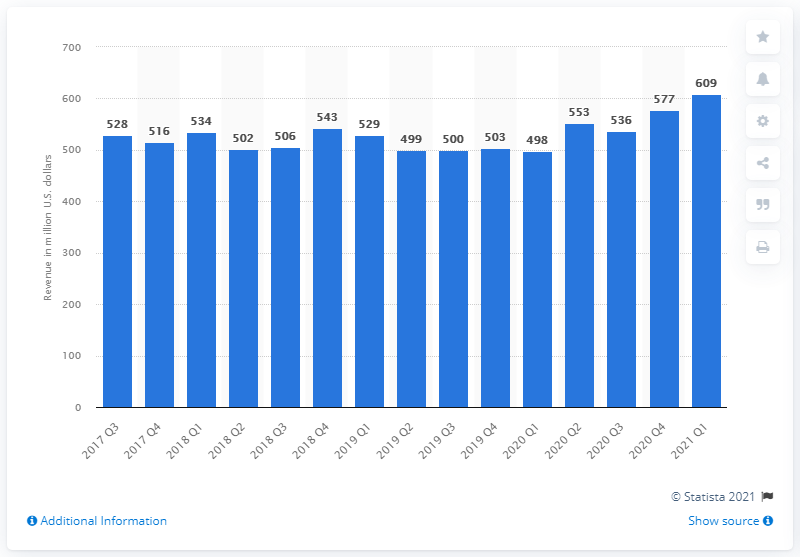Mention a couple of crucial points in this snapshot. In the first quarter of 2021, King generated approximately 609 dollars in revenue. 